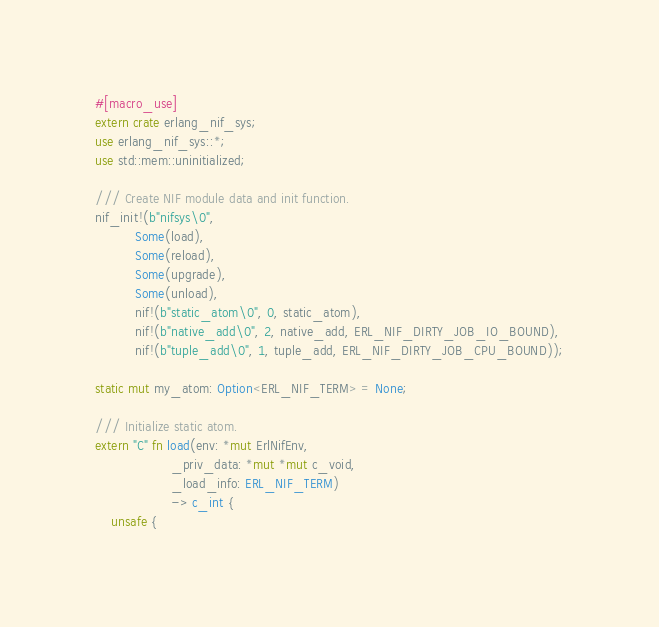<code> <loc_0><loc_0><loc_500><loc_500><_Rust_>#[macro_use]
extern crate erlang_nif_sys;
use erlang_nif_sys::*;
use std::mem::uninitialized;

/// Create NIF module data and init function.
nif_init!(b"nifsys\0",
          Some(load),
          Some(reload),
          Some(upgrade),
          Some(unload),
          nif!(b"static_atom\0", 0, static_atom),
          nif!(b"native_add\0", 2, native_add, ERL_NIF_DIRTY_JOB_IO_BOUND),
          nif!(b"tuple_add\0", 1, tuple_add, ERL_NIF_DIRTY_JOB_CPU_BOUND));

static mut my_atom: Option<ERL_NIF_TERM> = None;

/// Initialize static atom.
extern "C" fn load(env: *mut ErlNifEnv,
                   _priv_data: *mut *mut c_void,
                   _load_info: ERL_NIF_TERM)
                   -> c_int {
    unsafe {</code> 